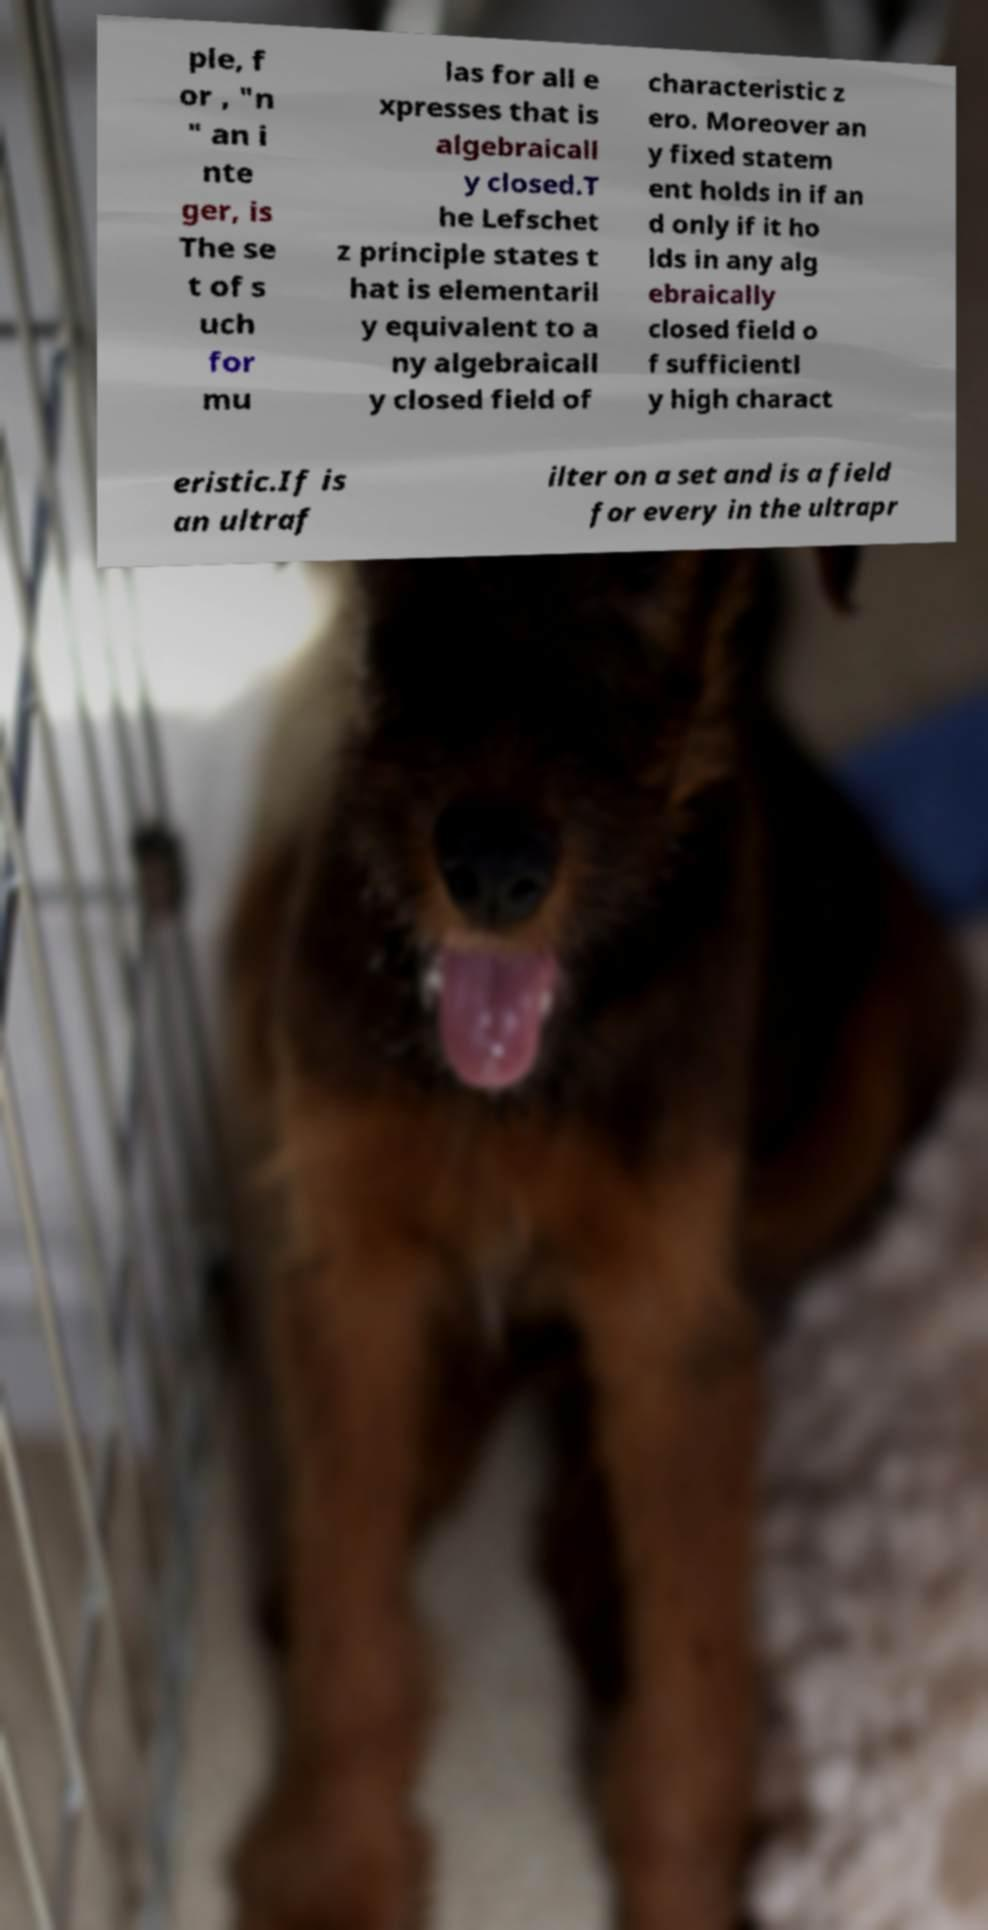I need the written content from this picture converted into text. Can you do that? ple, f or , "n " an i nte ger, is The se t of s uch for mu las for all e xpresses that is algebraicall y closed.T he Lefschet z principle states t hat is elementaril y equivalent to a ny algebraicall y closed field of characteristic z ero. Moreover an y fixed statem ent holds in if an d only if it ho lds in any alg ebraically closed field o f sufficientl y high charact eristic.If is an ultraf ilter on a set and is a field for every in the ultrapr 